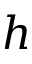Convert formula to latex. <formula><loc_0><loc_0><loc_500><loc_500>h</formula> 